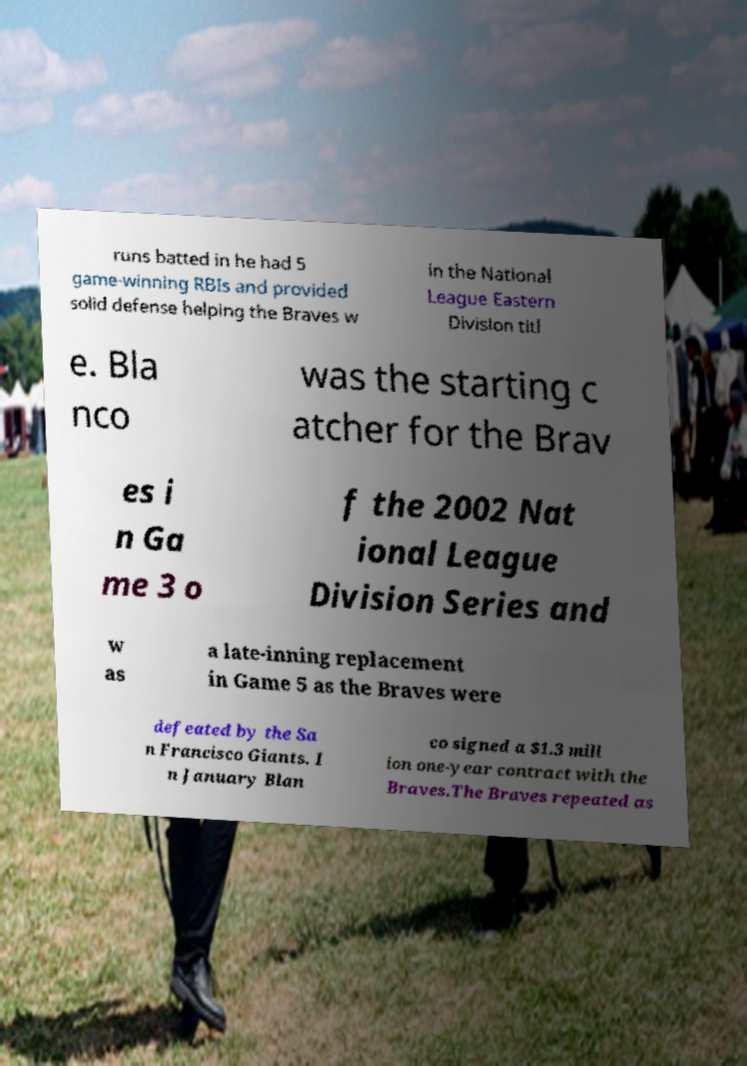Can you accurately transcribe the text from the provided image for me? runs batted in he had 5 game-winning RBIs and provided solid defense helping the Braves w in the National League Eastern Division titl e. Bla nco was the starting c atcher for the Brav es i n Ga me 3 o f the 2002 Nat ional League Division Series and w as a late-inning replacement in Game 5 as the Braves were defeated by the Sa n Francisco Giants. I n January Blan co signed a $1.3 mill ion one-year contract with the Braves.The Braves repeated as 